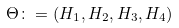<formula> <loc_0><loc_0><loc_500><loc_500>\Theta \colon = ( H _ { 1 } , H _ { 2 } , H _ { 3 } , H _ { 4 } )</formula> 